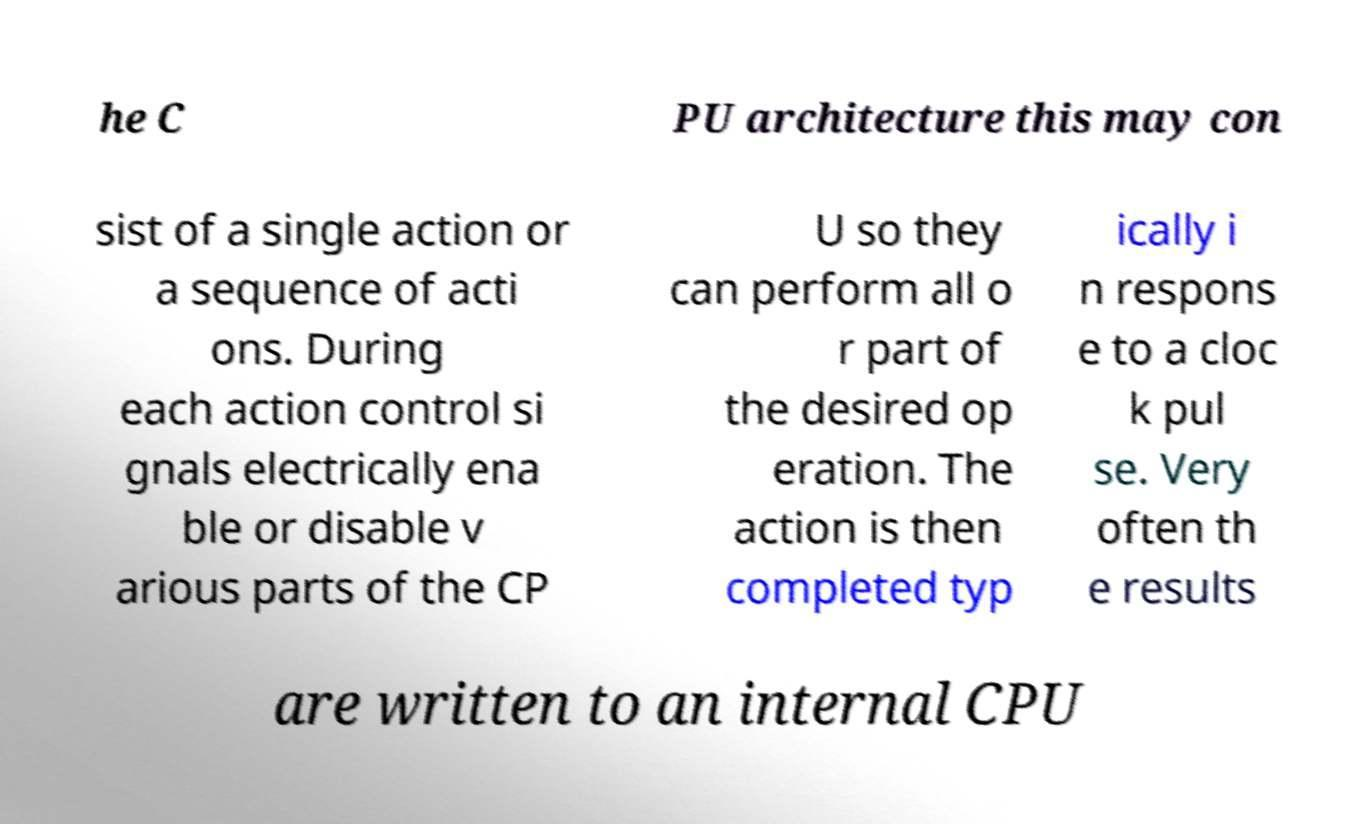Can you read and provide the text displayed in the image?This photo seems to have some interesting text. Can you extract and type it out for me? he C PU architecture this may con sist of a single action or a sequence of acti ons. During each action control si gnals electrically ena ble or disable v arious parts of the CP U so they can perform all o r part of the desired op eration. The action is then completed typ ically i n respons e to a cloc k pul se. Very often th e results are written to an internal CPU 